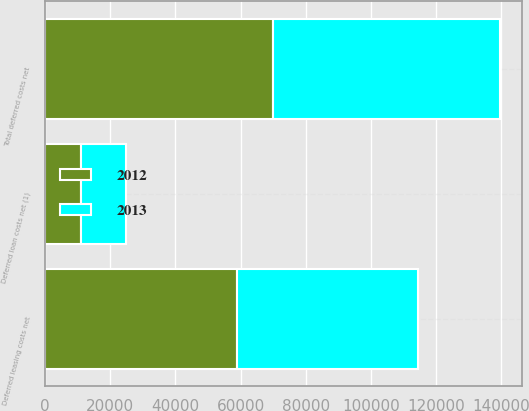Convert chart. <chart><loc_0><loc_0><loc_500><loc_500><stacked_bar_chart><ecel><fcel>Deferred leasing costs net<fcel>Deferred loan costs net (1)<fcel>Total deferred costs net<nl><fcel>2012<fcel>59027<fcel>10936<fcel>69963<nl><fcel>2013<fcel>55485<fcel>14021<fcel>69506<nl></chart> 